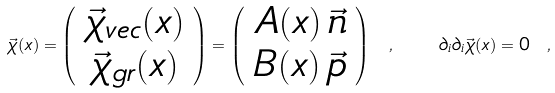<formula> <loc_0><loc_0><loc_500><loc_500>\vec { \chi } ( x ) = \left ( \begin{array} { c } { { \vec { \chi } _ { v e c } ( x ) } } \\ { { \vec { \chi } _ { g r } ( x ) } } \end{array} \right ) = \left ( \begin{array} { c } { { A ( x ) \, \vec { n } } } \\ { { B ( x ) \, \vec { p } } } \end{array} \right ) \ , \quad \partial _ { i } \partial _ { i } \vec { \chi } ( x ) = 0 \ ,</formula> 